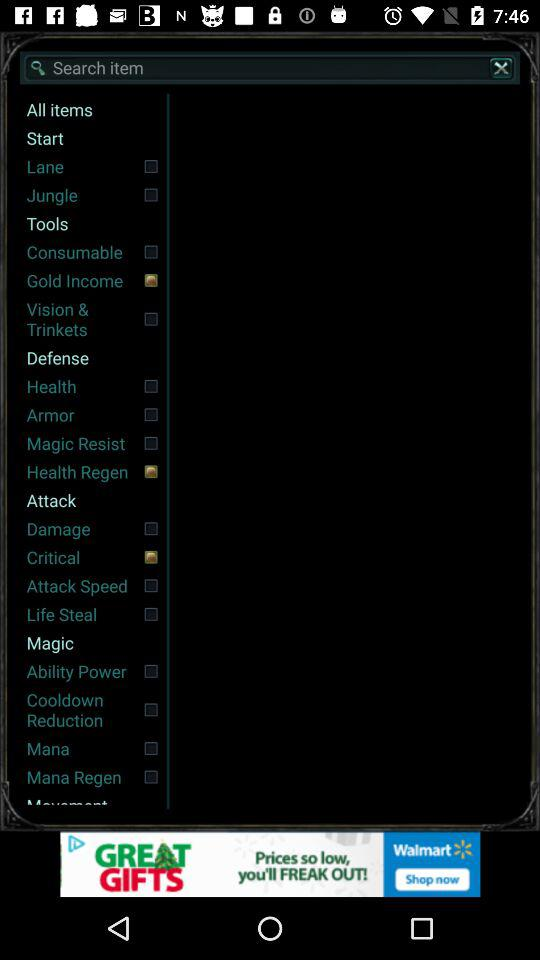Which item is not selected in "Tools"? The items that is not selected in "Tools" are "Consumable" and "Vision & Trinkets". 